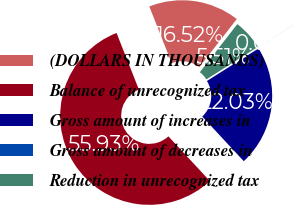Convert chart to OTSL. <chart><loc_0><loc_0><loc_500><loc_500><pie_chart><fcel>(DOLLARS IN THOUSANDS)<fcel>Balance of unrecognized tax<fcel>Gross amount of increases in<fcel>Gross amount of decreases in<fcel>Reduction in unrecognized tax<nl><fcel>16.52%<fcel>55.93%<fcel>22.03%<fcel>0.01%<fcel>5.51%<nl></chart> 